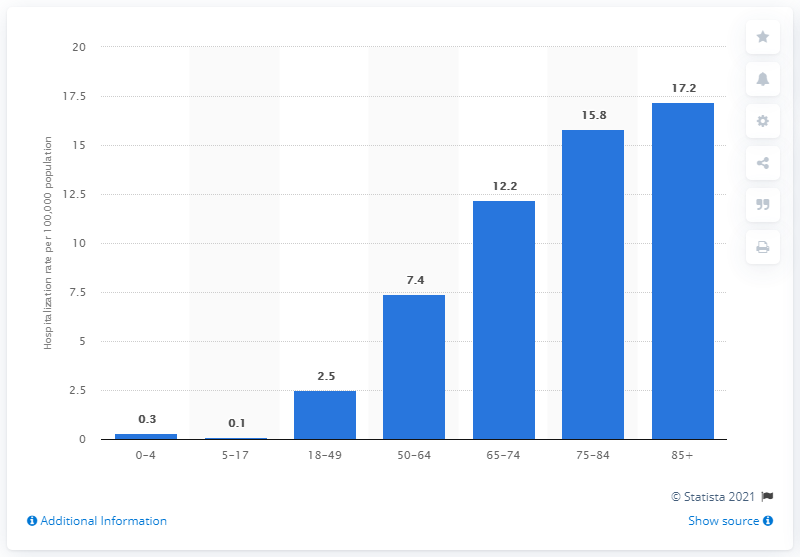Outline some significant characteristics in this image. The COVID-19 associated hospitalization rate per 100,000 population was 17.2. 